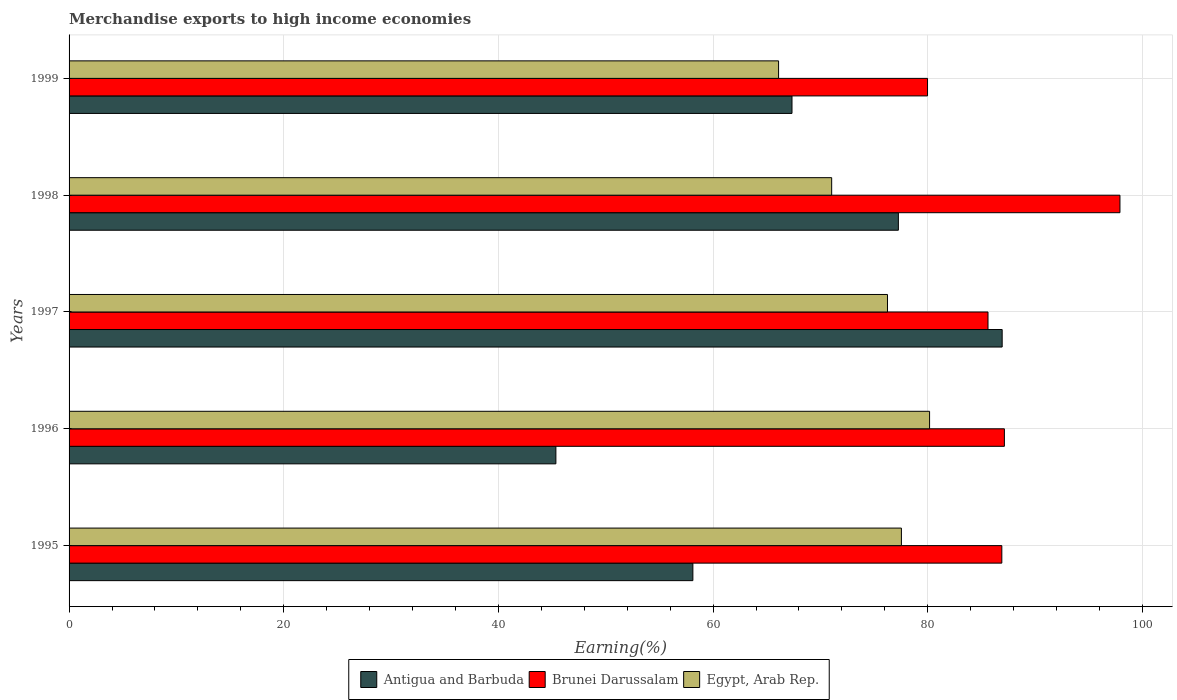How many different coloured bars are there?
Give a very brief answer. 3. How many groups of bars are there?
Your answer should be very brief. 5. Are the number of bars per tick equal to the number of legend labels?
Provide a short and direct response. Yes. How many bars are there on the 3rd tick from the bottom?
Offer a very short reply. 3. What is the percentage of amount earned from merchandise exports in Egypt, Arab Rep. in 1996?
Give a very brief answer. 80.17. Across all years, what is the maximum percentage of amount earned from merchandise exports in Antigua and Barbuda?
Offer a very short reply. 86.93. Across all years, what is the minimum percentage of amount earned from merchandise exports in Brunei Darussalam?
Give a very brief answer. 79.98. In which year was the percentage of amount earned from merchandise exports in Egypt, Arab Rep. maximum?
Provide a succinct answer. 1996. What is the total percentage of amount earned from merchandise exports in Brunei Darussalam in the graph?
Offer a very short reply. 437.52. What is the difference between the percentage of amount earned from merchandise exports in Brunei Darussalam in 1995 and that in 1997?
Make the answer very short. 1.29. What is the difference between the percentage of amount earned from merchandise exports in Antigua and Barbuda in 1998 and the percentage of amount earned from merchandise exports in Egypt, Arab Rep. in 1999?
Your answer should be compact. 11.16. What is the average percentage of amount earned from merchandise exports in Antigua and Barbuda per year?
Your answer should be very brief. 67. In the year 1999, what is the difference between the percentage of amount earned from merchandise exports in Brunei Darussalam and percentage of amount earned from merchandise exports in Antigua and Barbuda?
Your answer should be compact. 12.63. In how many years, is the percentage of amount earned from merchandise exports in Antigua and Barbuda greater than 76 %?
Provide a short and direct response. 2. What is the ratio of the percentage of amount earned from merchandise exports in Egypt, Arab Rep. in 1996 to that in 1997?
Your answer should be compact. 1.05. Is the percentage of amount earned from merchandise exports in Brunei Darussalam in 1995 less than that in 1999?
Provide a short and direct response. No. What is the difference between the highest and the second highest percentage of amount earned from merchandise exports in Antigua and Barbuda?
Your response must be concise. 9.67. What is the difference between the highest and the lowest percentage of amount earned from merchandise exports in Egypt, Arab Rep.?
Your response must be concise. 14.07. In how many years, is the percentage of amount earned from merchandise exports in Egypt, Arab Rep. greater than the average percentage of amount earned from merchandise exports in Egypt, Arab Rep. taken over all years?
Give a very brief answer. 3. What does the 1st bar from the top in 1997 represents?
Your response must be concise. Egypt, Arab Rep. What does the 2nd bar from the bottom in 1998 represents?
Keep it short and to the point. Brunei Darussalam. How many bars are there?
Your response must be concise. 15. Does the graph contain any zero values?
Offer a terse response. No. Does the graph contain grids?
Your answer should be very brief. Yes. Where does the legend appear in the graph?
Your response must be concise. Bottom center. How many legend labels are there?
Ensure brevity in your answer.  3. How are the legend labels stacked?
Keep it short and to the point. Horizontal. What is the title of the graph?
Provide a succinct answer. Merchandise exports to high income economies. Does "French Polynesia" appear as one of the legend labels in the graph?
Provide a succinct answer. No. What is the label or title of the X-axis?
Give a very brief answer. Earning(%). What is the Earning(%) of Antigua and Barbuda in 1995?
Offer a very short reply. 58.12. What is the Earning(%) of Brunei Darussalam in 1995?
Keep it short and to the point. 86.9. What is the Earning(%) in Egypt, Arab Rep. in 1995?
Ensure brevity in your answer.  77.54. What is the Earning(%) in Antigua and Barbuda in 1996?
Ensure brevity in your answer.  45.35. What is the Earning(%) of Brunei Darussalam in 1996?
Keep it short and to the point. 87.14. What is the Earning(%) in Egypt, Arab Rep. in 1996?
Offer a terse response. 80.17. What is the Earning(%) in Antigua and Barbuda in 1997?
Offer a very short reply. 86.93. What is the Earning(%) of Brunei Darussalam in 1997?
Offer a very short reply. 85.61. What is the Earning(%) in Egypt, Arab Rep. in 1997?
Your answer should be very brief. 76.25. What is the Earning(%) in Antigua and Barbuda in 1998?
Keep it short and to the point. 77.26. What is the Earning(%) of Brunei Darussalam in 1998?
Make the answer very short. 97.9. What is the Earning(%) in Egypt, Arab Rep. in 1998?
Your answer should be compact. 71.05. What is the Earning(%) in Antigua and Barbuda in 1999?
Provide a succinct answer. 67.35. What is the Earning(%) in Brunei Darussalam in 1999?
Your answer should be very brief. 79.98. What is the Earning(%) of Egypt, Arab Rep. in 1999?
Ensure brevity in your answer.  66.1. Across all years, what is the maximum Earning(%) of Antigua and Barbuda?
Give a very brief answer. 86.93. Across all years, what is the maximum Earning(%) of Brunei Darussalam?
Your response must be concise. 97.9. Across all years, what is the maximum Earning(%) of Egypt, Arab Rep.?
Your response must be concise. 80.17. Across all years, what is the minimum Earning(%) of Antigua and Barbuda?
Give a very brief answer. 45.35. Across all years, what is the minimum Earning(%) of Brunei Darussalam?
Offer a terse response. 79.98. Across all years, what is the minimum Earning(%) of Egypt, Arab Rep.?
Your answer should be very brief. 66.1. What is the total Earning(%) in Antigua and Barbuda in the graph?
Ensure brevity in your answer.  335.01. What is the total Earning(%) in Brunei Darussalam in the graph?
Offer a terse response. 437.52. What is the total Earning(%) in Egypt, Arab Rep. in the graph?
Your answer should be very brief. 371.1. What is the difference between the Earning(%) in Antigua and Barbuda in 1995 and that in 1996?
Give a very brief answer. 12.76. What is the difference between the Earning(%) in Brunei Darussalam in 1995 and that in 1996?
Your answer should be compact. -0.24. What is the difference between the Earning(%) of Egypt, Arab Rep. in 1995 and that in 1996?
Give a very brief answer. -2.63. What is the difference between the Earning(%) in Antigua and Barbuda in 1995 and that in 1997?
Provide a succinct answer. -28.81. What is the difference between the Earning(%) in Brunei Darussalam in 1995 and that in 1997?
Provide a succinct answer. 1.29. What is the difference between the Earning(%) in Egypt, Arab Rep. in 1995 and that in 1997?
Keep it short and to the point. 1.3. What is the difference between the Earning(%) in Antigua and Barbuda in 1995 and that in 1998?
Provide a short and direct response. -19.15. What is the difference between the Earning(%) in Brunei Darussalam in 1995 and that in 1998?
Your answer should be compact. -11. What is the difference between the Earning(%) in Egypt, Arab Rep. in 1995 and that in 1998?
Offer a terse response. 6.5. What is the difference between the Earning(%) in Antigua and Barbuda in 1995 and that in 1999?
Offer a terse response. -9.23. What is the difference between the Earning(%) of Brunei Darussalam in 1995 and that in 1999?
Keep it short and to the point. 6.92. What is the difference between the Earning(%) of Egypt, Arab Rep. in 1995 and that in 1999?
Provide a succinct answer. 11.44. What is the difference between the Earning(%) in Antigua and Barbuda in 1996 and that in 1997?
Your answer should be compact. -41.58. What is the difference between the Earning(%) in Brunei Darussalam in 1996 and that in 1997?
Provide a succinct answer. 1.53. What is the difference between the Earning(%) in Egypt, Arab Rep. in 1996 and that in 1997?
Provide a short and direct response. 3.92. What is the difference between the Earning(%) in Antigua and Barbuda in 1996 and that in 1998?
Offer a terse response. -31.91. What is the difference between the Earning(%) of Brunei Darussalam in 1996 and that in 1998?
Provide a short and direct response. -10.77. What is the difference between the Earning(%) of Egypt, Arab Rep. in 1996 and that in 1998?
Your response must be concise. 9.12. What is the difference between the Earning(%) in Antigua and Barbuda in 1996 and that in 1999?
Keep it short and to the point. -22. What is the difference between the Earning(%) in Brunei Darussalam in 1996 and that in 1999?
Make the answer very short. 7.16. What is the difference between the Earning(%) of Egypt, Arab Rep. in 1996 and that in 1999?
Keep it short and to the point. 14.07. What is the difference between the Earning(%) in Antigua and Barbuda in 1997 and that in 1998?
Provide a short and direct response. 9.67. What is the difference between the Earning(%) in Brunei Darussalam in 1997 and that in 1998?
Give a very brief answer. -12.29. What is the difference between the Earning(%) in Egypt, Arab Rep. in 1997 and that in 1998?
Keep it short and to the point. 5.2. What is the difference between the Earning(%) of Antigua and Barbuda in 1997 and that in 1999?
Offer a terse response. 19.58. What is the difference between the Earning(%) in Brunei Darussalam in 1997 and that in 1999?
Offer a very short reply. 5.63. What is the difference between the Earning(%) of Egypt, Arab Rep. in 1997 and that in 1999?
Give a very brief answer. 10.15. What is the difference between the Earning(%) of Antigua and Barbuda in 1998 and that in 1999?
Provide a succinct answer. 9.91. What is the difference between the Earning(%) in Brunei Darussalam in 1998 and that in 1999?
Your answer should be very brief. 17.93. What is the difference between the Earning(%) in Egypt, Arab Rep. in 1998 and that in 1999?
Your answer should be very brief. 4.95. What is the difference between the Earning(%) in Antigua and Barbuda in 1995 and the Earning(%) in Brunei Darussalam in 1996?
Offer a terse response. -29.02. What is the difference between the Earning(%) of Antigua and Barbuda in 1995 and the Earning(%) of Egypt, Arab Rep. in 1996?
Provide a short and direct response. -22.05. What is the difference between the Earning(%) in Brunei Darussalam in 1995 and the Earning(%) in Egypt, Arab Rep. in 1996?
Make the answer very short. 6.73. What is the difference between the Earning(%) of Antigua and Barbuda in 1995 and the Earning(%) of Brunei Darussalam in 1997?
Make the answer very short. -27.5. What is the difference between the Earning(%) of Antigua and Barbuda in 1995 and the Earning(%) of Egypt, Arab Rep. in 1997?
Ensure brevity in your answer.  -18.13. What is the difference between the Earning(%) in Brunei Darussalam in 1995 and the Earning(%) in Egypt, Arab Rep. in 1997?
Make the answer very short. 10.65. What is the difference between the Earning(%) in Antigua and Barbuda in 1995 and the Earning(%) in Brunei Darussalam in 1998?
Make the answer very short. -39.79. What is the difference between the Earning(%) in Antigua and Barbuda in 1995 and the Earning(%) in Egypt, Arab Rep. in 1998?
Provide a succinct answer. -12.93. What is the difference between the Earning(%) of Brunei Darussalam in 1995 and the Earning(%) of Egypt, Arab Rep. in 1998?
Provide a succinct answer. 15.85. What is the difference between the Earning(%) of Antigua and Barbuda in 1995 and the Earning(%) of Brunei Darussalam in 1999?
Your answer should be very brief. -21.86. What is the difference between the Earning(%) in Antigua and Barbuda in 1995 and the Earning(%) in Egypt, Arab Rep. in 1999?
Give a very brief answer. -7.98. What is the difference between the Earning(%) in Brunei Darussalam in 1995 and the Earning(%) in Egypt, Arab Rep. in 1999?
Provide a succinct answer. 20.8. What is the difference between the Earning(%) of Antigua and Barbuda in 1996 and the Earning(%) of Brunei Darussalam in 1997?
Ensure brevity in your answer.  -40.26. What is the difference between the Earning(%) in Antigua and Barbuda in 1996 and the Earning(%) in Egypt, Arab Rep. in 1997?
Ensure brevity in your answer.  -30.89. What is the difference between the Earning(%) of Brunei Darussalam in 1996 and the Earning(%) of Egypt, Arab Rep. in 1997?
Provide a short and direct response. 10.89. What is the difference between the Earning(%) of Antigua and Barbuda in 1996 and the Earning(%) of Brunei Darussalam in 1998?
Provide a short and direct response. -52.55. What is the difference between the Earning(%) in Antigua and Barbuda in 1996 and the Earning(%) in Egypt, Arab Rep. in 1998?
Ensure brevity in your answer.  -25.69. What is the difference between the Earning(%) of Brunei Darussalam in 1996 and the Earning(%) of Egypt, Arab Rep. in 1998?
Your response must be concise. 16.09. What is the difference between the Earning(%) in Antigua and Barbuda in 1996 and the Earning(%) in Brunei Darussalam in 1999?
Offer a very short reply. -34.62. What is the difference between the Earning(%) in Antigua and Barbuda in 1996 and the Earning(%) in Egypt, Arab Rep. in 1999?
Provide a short and direct response. -20.75. What is the difference between the Earning(%) in Brunei Darussalam in 1996 and the Earning(%) in Egypt, Arab Rep. in 1999?
Offer a terse response. 21.04. What is the difference between the Earning(%) of Antigua and Barbuda in 1997 and the Earning(%) of Brunei Darussalam in 1998?
Offer a very short reply. -10.97. What is the difference between the Earning(%) of Antigua and Barbuda in 1997 and the Earning(%) of Egypt, Arab Rep. in 1998?
Offer a terse response. 15.88. What is the difference between the Earning(%) in Brunei Darussalam in 1997 and the Earning(%) in Egypt, Arab Rep. in 1998?
Offer a very short reply. 14.56. What is the difference between the Earning(%) in Antigua and Barbuda in 1997 and the Earning(%) in Brunei Darussalam in 1999?
Your answer should be very brief. 6.95. What is the difference between the Earning(%) of Antigua and Barbuda in 1997 and the Earning(%) of Egypt, Arab Rep. in 1999?
Offer a very short reply. 20.83. What is the difference between the Earning(%) of Brunei Darussalam in 1997 and the Earning(%) of Egypt, Arab Rep. in 1999?
Make the answer very short. 19.51. What is the difference between the Earning(%) in Antigua and Barbuda in 1998 and the Earning(%) in Brunei Darussalam in 1999?
Make the answer very short. -2.71. What is the difference between the Earning(%) of Antigua and Barbuda in 1998 and the Earning(%) of Egypt, Arab Rep. in 1999?
Provide a short and direct response. 11.16. What is the difference between the Earning(%) in Brunei Darussalam in 1998 and the Earning(%) in Egypt, Arab Rep. in 1999?
Give a very brief answer. 31.8. What is the average Earning(%) of Antigua and Barbuda per year?
Your answer should be very brief. 67. What is the average Earning(%) of Brunei Darussalam per year?
Your response must be concise. 87.5. What is the average Earning(%) in Egypt, Arab Rep. per year?
Provide a short and direct response. 74.22. In the year 1995, what is the difference between the Earning(%) in Antigua and Barbuda and Earning(%) in Brunei Darussalam?
Your answer should be very brief. -28.78. In the year 1995, what is the difference between the Earning(%) in Antigua and Barbuda and Earning(%) in Egypt, Arab Rep.?
Your answer should be very brief. -19.43. In the year 1995, what is the difference between the Earning(%) of Brunei Darussalam and Earning(%) of Egypt, Arab Rep.?
Provide a succinct answer. 9.36. In the year 1996, what is the difference between the Earning(%) of Antigua and Barbuda and Earning(%) of Brunei Darussalam?
Offer a very short reply. -41.78. In the year 1996, what is the difference between the Earning(%) in Antigua and Barbuda and Earning(%) in Egypt, Arab Rep.?
Provide a short and direct response. -34.81. In the year 1996, what is the difference between the Earning(%) of Brunei Darussalam and Earning(%) of Egypt, Arab Rep.?
Make the answer very short. 6.97. In the year 1997, what is the difference between the Earning(%) of Antigua and Barbuda and Earning(%) of Brunei Darussalam?
Provide a short and direct response. 1.32. In the year 1997, what is the difference between the Earning(%) of Antigua and Barbuda and Earning(%) of Egypt, Arab Rep.?
Keep it short and to the point. 10.68. In the year 1997, what is the difference between the Earning(%) in Brunei Darussalam and Earning(%) in Egypt, Arab Rep.?
Provide a succinct answer. 9.37. In the year 1998, what is the difference between the Earning(%) of Antigua and Barbuda and Earning(%) of Brunei Darussalam?
Offer a terse response. -20.64. In the year 1998, what is the difference between the Earning(%) of Antigua and Barbuda and Earning(%) of Egypt, Arab Rep.?
Give a very brief answer. 6.21. In the year 1998, what is the difference between the Earning(%) of Brunei Darussalam and Earning(%) of Egypt, Arab Rep.?
Keep it short and to the point. 26.86. In the year 1999, what is the difference between the Earning(%) of Antigua and Barbuda and Earning(%) of Brunei Darussalam?
Provide a succinct answer. -12.63. In the year 1999, what is the difference between the Earning(%) in Antigua and Barbuda and Earning(%) in Egypt, Arab Rep.?
Your answer should be compact. 1.25. In the year 1999, what is the difference between the Earning(%) of Brunei Darussalam and Earning(%) of Egypt, Arab Rep.?
Offer a terse response. 13.88. What is the ratio of the Earning(%) in Antigua and Barbuda in 1995 to that in 1996?
Provide a short and direct response. 1.28. What is the ratio of the Earning(%) of Brunei Darussalam in 1995 to that in 1996?
Offer a very short reply. 1. What is the ratio of the Earning(%) of Egypt, Arab Rep. in 1995 to that in 1996?
Provide a succinct answer. 0.97. What is the ratio of the Earning(%) of Antigua and Barbuda in 1995 to that in 1997?
Provide a succinct answer. 0.67. What is the ratio of the Earning(%) in Egypt, Arab Rep. in 1995 to that in 1997?
Provide a succinct answer. 1.02. What is the ratio of the Earning(%) in Antigua and Barbuda in 1995 to that in 1998?
Provide a succinct answer. 0.75. What is the ratio of the Earning(%) in Brunei Darussalam in 1995 to that in 1998?
Offer a terse response. 0.89. What is the ratio of the Earning(%) in Egypt, Arab Rep. in 1995 to that in 1998?
Offer a very short reply. 1.09. What is the ratio of the Earning(%) in Antigua and Barbuda in 1995 to that in 1999?
Make the answer very short. 0.86. What is the ratio of the Earning(%) of Brunei Darussalam in 1995 to that in 1999?
Your answer should be compact. 1.09. What is the ratio of the Earning(%) in Egypt, Arab Rep. in 1995 to that in 1999?
Offer a terse response. 1.17. What is the ratio of the Earning(%) of Antigua and Barbuda in 1996 to that in 1997?
Offer a very short reply. 0.52. What is the ratio of the Earning(%) in Brunei Darussalam in 1996 to that in 1997?
Ensure brevity in your answer.  1.02. What is the ratio of the Earning(%) of Egypt, Arab Rep. in 1996 to that in 1997?
Your answer should be very brief. 1.05. What is the ratio of the Earning(%) in Antigua and Barbuda in 1996 to that in 1998?
Your response must be concise. 0.59. What is the ratio of the Earning(%) in Brunei Darussalam in 1996 to that in 1998?
Make the answer very short. 0.89. What is the ratio of the Earning(%) of Egypt, Arab Rep. in 1996 to that in 1998?
Your answer should be compact. 1.13. What is the ratio of the Earning(%) in Antigua and Barbuda in 1996 to that in 1999?
Ensure brevity in your answer.  0.67. What is the ratio of the Earning(%) of Brunei Darussalam in 1996 to that in 1999?
Make the answer very short. 1.09. What is the ratio of the Earning(%) of Egypt, Arab Rep. in 1996 to that in 1999?
Offer a terse response. 1.21. What is the ratio of the Earning(%) of Antigua and Barbuda in 1997 to that in 1998?
Your answer should be compact. 1.13. What is the ratio of the Earning(%) in Brunei Darussalam in 1997 to that in 1998?
Your answer should be very brief. 0.87. What is the ratio of the Earning(%) of Egypt, Arab Rep. in 1997 to that in 1998?
Give a very brief answer. 1.07. What is the ratio of the Earning(%) in Antigua and Barbuda in 1997 to that in 1999?
Offer a very short reply. 1.29. What is the ratio of the Earning(%) in Brunei Darussalam in 1997 to that in 1999?
Provide a succinct answer. 1.07. What is the ratio of the Earning(%) in Egypt, Arab Rep. in 1997 to that in 1999?
Your answer should be very brief. 1.15. What is the ratio of the Earning(%) in Antigua and Barbuda in 1998 to that in 1999?
Provide a succinct answer. 1.15. What is the ratio of the Earning(%) in Brunei Darussalam in 1998 to that in 1999?
Provide a succinct answer. 1.22. What is the ratio of the Earning(%) in Egypt, Arab Rep. in 1998 to that in 1999?
Provide a succinct answer. 1.07. What is the difference between the highest and the second highest Earning(%) of Antigua and Barbuda?
Make the answer very short. 9.67. What is the difference between the highest and the second highest Earning(%) of Brunei Darussalam?
Your response must be concise. 10.77. What is the difference between the highest and the second highest Earning(%) in Egypt, Arab Rep.?
Your answer should be very brief. 2.63. What is the difference between the highest and the lowest Earning(%) in Antigua and Barbuda?
Give a very brief answer. 41.58. What is the difference between the highest and the lowest Earning(%) of Brunei Darussalam?
Your response must be concise. 17.93. What is the difference between the highest and the lowest Earning(%) of Egypt, Arab Rep.?
Make the answer very short. 14.07. 